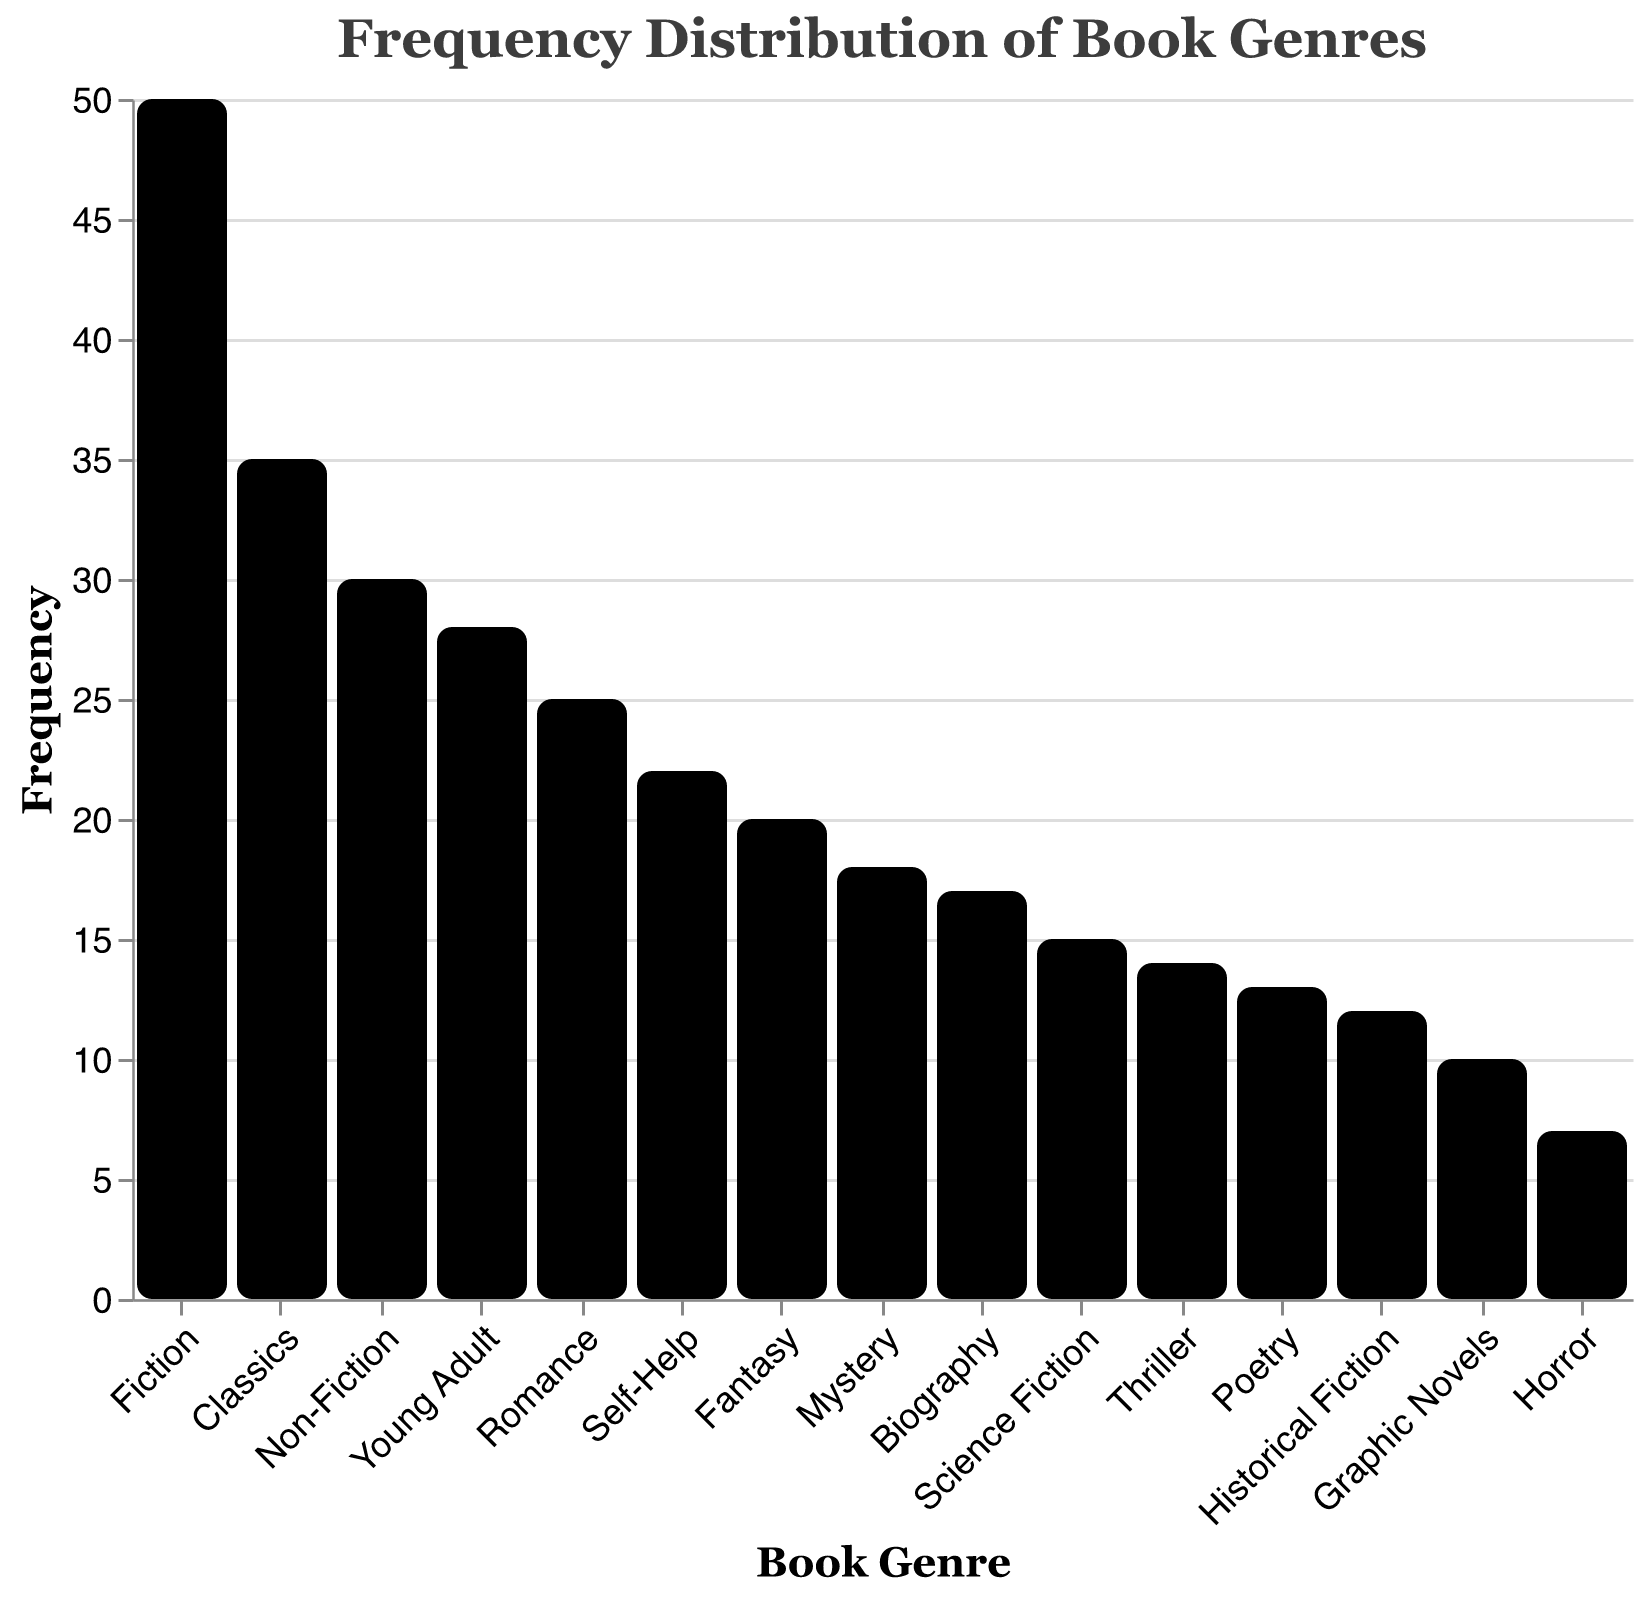What's the most frequently preferred book genre among college students? The visual reveals the height of each bar, and the tallest bar corresponds to Fiction with a frequency of 50.
Answer: Fiction Which genres have a frequency lower than 20? By observing the heights of the bars below the 20 mark on the y-axis, we identify Fantasy, Science Fiction, Mystery, Historical Fiction, Biography, Thriller, Graphic Novels, Horror, and Poetry.
Answer: Fantasy, Science Fiction, Mystery, Historical Fiction, Biography, Thriller, Graphic Novels, Horror, Poetry What is the total frequency of Fiction, Non-Fiction, and Classics combined? Adding the frequencies of Fiction (50), Non-Fiction (30), and Classics (35), results in 50 + 30 + 35 = 115.
Answer: 115 Which genre has a higher frequency, Poetry or Science Fiction? By comparing the heights of the bars, Science Fiction has a frequency of 15 while Poetry has 13, thus Science Fiction is higher.
Answer: Science Fiction How many book genres have a frequency greater than 25? The genres with bars extending beyond the 25 mark are Fiction, Non-Fiction, Romance, Young Adult, and Classics, making a total of 5 genres.
Answer: 5 What is the difference in frequency between the most and least preferred genres? The most preferred genre is Fiction (50) and the least preferred is Horror (7). The difference is 50 - 7 = 43.
Answer: 43 Which genre appears more popular: Mystery or Biography? Comparing the bars, Mystery has a frequency of 18 while Biography has 17, making Mystery slightly more popular.
Answer: Mystery What is the total frequency of genres with "Fiction" in their names? Summing up Fiction (50), Science Fiction (15), and Historical Fiction (12) results in 50 + 15 + 12 = 77.
Answer: 77 What percentage of the total frequency does Young Adult comprise? The total frequency is 50 + 30 + 20 + 15 + 25 + 18 + 12 + 17 + 22 + 14 + 28 + 10 + 35 + 7 + 13 = 316. Young Adult's frequency is 28. The percentage is (28 / 316) * 100 ≈ 8.86%.
Answer: 8.86% Between Graphic Novels and Horror, which genre has the least frequency? The bar for Horror is shorter with a frequency of 7, compared to Graphic Novels' frequency of 10.
Answer: Horror 